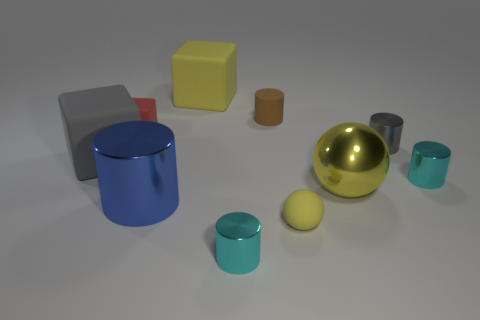The large rubber thing to the right of the red thing has what shape?
Your answer should be compact. Cube. There is a big yellow object that is right of the rubber thing that is in front of the large matte thing in front of the red rubber cube; what is its shape?
Provide a succinct answer. Sphere. How many objects are small matte cylinders or big red things?
Ensure brevity in your answer.  1. Do the tiny rubber thing to the right of the small brown cylinder and the brown thing that is right of the large yellow matte object have the same shape?
Make the answer very short. No. What number of big rubber blocks are both in front of the tiny red rubber thing and on the right side of the tiny matte cube?
Offer a terse response. 0. What number of other objects are there of the same size as the brown cylinder?
Your answer should be compact. 5. What is the material of the block that is both in front of the brown matte thing and behind the gray metal object?
Your response must be concise. Rubber. There is a large shiny sphere; is its color the same as the large cube that is behind the red object?
Offer a terse response. Yes. What is the size of the blue thing that is the same shape as the brown matte object?
Give a very brief answer. Large. The big object that is both behind the shiny ball and to the right of the large gray object has what shape?
Your answer should be compact. Cube. 